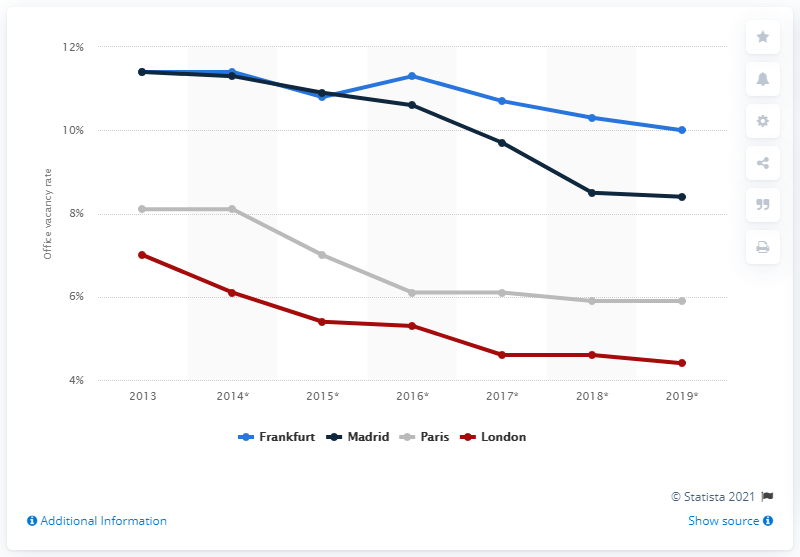Outline some significant characteristics in this image. In 2013, the office vacancy rates in Frankfurt and Madrid were 11.4%. In 2013, it was projected that the office vacancy rates in Madrid would decrease by approximately 10%. In 2013, the highest office vacancy rates were recorded in Frankfurt and Madrid. 